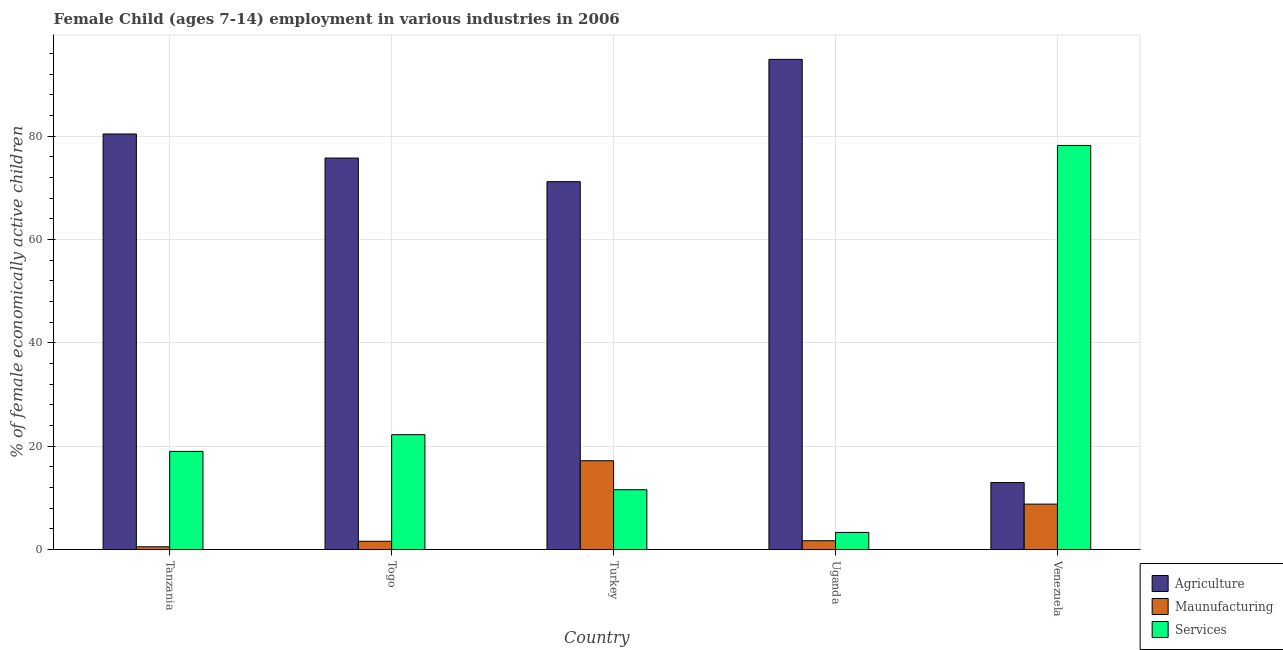How many groups of bars are there?
Ensure brevity in your answer.  5. Are the number of bars per tick equal to the number of legend labels?
Ensure brevity in your answer.  Yes. How many bars are there on the 1st tick from the left?
Make the answer very short. 3. How many bars are there on the 1st tick from the right?
Your answer should be compact. 3. What is the label of the 5th group of bars from the left?
Provide a short and direct response. Venezuela. What is the percentage of economically active children in manufacturing in Uganda?
Your response must be concise. 1.71. Across all countries, what is the maximum percentage of economically active children in manufacturing?
Your answer should be very brief. 17.2. Across all countries, what is the minimum percentage of economically active children in agriculture?
Provide a short and direct response. 12.97. In which country was the percentage of economically active children in services maximum?
Offer a terse response. Venezuela. In which country was the percentage of economically active children in manufacturing minimum?
Your answer should be compact. Tanzania. What is the total percentage of economically active children in agriculture in the graph?
Your answer should be compact. 335.32. What is the difference between the percentage of economically active children in services in Tanzania and that in Togo?
Ensure brevity in your answer.  -3.23. What is the difference between the percentage of economically active children in agriculture in Togo and the percentage of economically active children in manufacturing in Tanzania?
Provide a short and direct response. 75.25. What is the average percentage of economically active children in agriculture per country?
Provide a succinct answer. 67.06. What is the difference between the percentage of economically active children in manufacturing and percentage of economically active children in agriculture in Turkey?
Offer a very short reply. -54.02. In how many countries, is the percentage of economically active children in manufacturing greater than 32 %?
Ensure brevity in your answer.  0. What is the ratio of the percentage of economically active children in agriculture in Turkey to that in Venezuela?
Offer a terse response. 5.49. Is the percentage of economically active children in manufacturing in Togo less than that in Uganda?
Your response must be concise. Yes. What is the difference between the highest and the second highest percentage of economically active children in manufacturing?
Ensure brevity in your answer.  8.4. What is the difference between the highest and the lowest percentage of economically active children in services?
Your answer should be very brief. 74.91. What does the 3rd bar from the left in Venezuela represents?
Ensure brevity in your answer.  Services. What does the 2nd bar from the right in Togo represents?
Provide a short and direct response. Maunufacturing. How many bars are there?
Provide a succinct answer. 15. Are all the bars in the graph horizontal?
Offer a very short reply. No. How many countries are there in the graph?
Make the answer very short. 5. Does the graph contain any zero values?
Provide a succinct answer. No. What is the title of the graph?
Offer a very short reply. Female Child (ages 7-14) employment in various industries in 2006. What is the label or title of the Y-axis?
Your answer should be compact. % of female economically active children. What is the % of female economically active children of Agriculture in Tanzania?
Your response must be concise. 80.45. What is the % of female economically active children of Maunufacturing in Tanzania?
Your response must be concise. 0.54. What is the % of female economically active children of Services in Tanzania?
Your answer should be compact. 19.01. What is the % of female economically active children in Agriculture in Togo?
Provide a short and direct response. 75.79. What is the % of female economically active children of Maunufacturing in Togo?
Make the answer very short. 1.61. What is the % of female economically active children of Services in Togo?
Provide a succinct answer. 22.24. What is the % of female economically active children in Agriculture in Turkey?
Make the answer very short. 71.22. What is the % of female economically active children in Services in Turkey?
Provide a short and direct response. 11.58. What is the % of female economically active children of Agriculture in Uganda?
Offer a very short reply. 94.89. What is the % of female economically active children in Maunufacturing in Uganda?
Offer a very short reply. 1.71. What is the % of female economically active children in Services in Uganda?
Offer a very short reply. 3.32. What is the % of female economically active children of Agriculture in Venezuela?
Your response must be concise. 12.97. What is the % of female economically active children of Services in Venezuela?
Offer a very short reply. 78.23. Across all countries, what is the maximum % of female economically active children in Agriculture?
Offer a very short reply. 94.89. Across all countries, what is the maximum % of female economically active children of Services?
Your answer should be very brief. 78.23. Across all countries, what is the minimum % of female economically active children of Agriculture?
Your response must be concise. 12.97. Across all countries, what is the minimum % of female economically active children in Maunufacturing?
Provide a short and direct response. 0.54. Across all countries, what is the minimum % of female economically active children of Services?
Ensure brevity in your answer.  3.32. What is the total % of female economically active children in Agriculture in the graph?
Your response must be concise. 335.32. What is the total % of female economically active children in Maunufacturing in the graph?
Keep it short and to the point. 29.86. What is the total % of female economically active children in Services in the graph?
Keep it short and to the point. 134.38. What is the difference between the % of female economically active children of Agriculture in Tanzania and that in Togo?
Keep it short and to the point. 4.66. What is the difference between the % of female economically active children in Maunufacturing in Tanzania and that in Togo?
Ensure brevity in your answer.  -1.07. What is the difference between the % of female economically active children in Services in Tanzania and that in Togo?
Offer a terse response. -3.23. What is the difference between the % of female economically active children of Agriculture in Tanzania and that in Turkey?
Your response must be concise. 9.23. What is the difference between the % of female economically active children in Maunufacturing in Tanzania and that in Turkey?
Provide a succinct answer. -16.66. What is the difference between the % of female economically active children of Services in Tanzania and that in Turkey?
Provide a succinct answer. 7.43. What is the difference between the % of female economically active children of Agriculture in Tanzania and that in Uganda?
Give a very brief answer. -14.44. What is the difference between the % of female economically active children in Maunufacturing in Tanzania and that in Uganda?
Your answer should be compact. -1.17. What is the difference between the % of female economically active children in Services in Tanzania and that in Uganda?
Give a very brief answer. 15.69. What is the difference between the % of female economically active children of Agriculture in Tanzania and that in Venezuela?
Give a very brief answer. 67.48. What is the difference between the % of female economically active children in Maunufacturing in Tanzania and that in Venezuela?
Your response must be concise. -8.26. What is the difference between the % of female economically active children of Services in Tanzania and that in Venezuela?
Offer a terse response. -59.22. What is the difference between the % of female economically active children of Agriculture in Togo and that in Turkey?
Ensure brevity in your answer.  4.57. What is the difference between the % of female economically active children of Maunufacturing in Togo and that in Turkey?
Provide a short and direct response. -15.59. What is the difference between the % of female economically active children in Services in Togo and that in Turkey?
Your response must be concise. 10.66. What is the difference between the % of female economically active children of Agriculture in Togo and that in Uganda?
Your answer should be very brief. -19.1. What is the difference between the % of female economically active children of Maunufacturing in Togo and that in Uganda?
Your response must be concise. -0.1. What is the difference between the % of female economically active children in Services in Togo and that in Uganda?
Offer a very short reply. 18.92. What is the difference between the % of female economically active children in Agriculture in Togo and that in Venezuela?
Keep it short and to the point. 62.82. What is the difference between the % of female economically active children of Maunufacturing in Togo and that in Venezuela?
Offer a very short reply. -7.19. What is the difference between the % of female economically active children of Services in Togo and that in Venezuela?
Make the answer very short. -55.99. What is the difference between the % of female economically active children of Agriculture in Turkey and that in Uganda?
Keep it short and to the point. -23.67. What is the difference between the % of female economically active children of Maunufacturing in Turkey and that in Uganda?
Give a very brief answer. 15.49. What is the difference between the % of female economically active children in Services in Turkey and that in Uganda?
Keep it short and to the point. 8.26. What is the difference between the % of female economically active children of Agriculture in Turkey and that in Venezuela?
Your answer should be compact. 58.25. What is the difference between the % of female economically active children in Services in Turkey and that in Venezuela?
Offer a very short reply. -66.65. What is the difference between the % of female economically active children in Agriculture in Uganda and that in Venezuela?
Your answer should be very brief. 81.92. What is the difference between the % of female economically active children of Maunufacturing in Uganda and that in Venezuela?
Provide a short and direct response. -7.09. What is the difference between the % of female economically active children in Services in Uganda and that in Venezuela?
Your answer should be compact. -74.91. What is the difference between the % of female economically active children in Agriculture in Tanzania and the % of female economically active children in Maunufacturing in Togo?
Offer a very short reply. 78.84. What is the difference between the % of female economically active children of Agriculture in Tanzania and the % of female economically active children of Services in Togo?
Provide a short and direct response. 58.21. What is the difference between the % of female economically active children in Maunufacturing in Tanzania and the % of female economically active children in Services in Togo?
Ensure brevity in your answer.  -21.7. What is the difference between the % of female economically active children of Agriculture in Tanzania and the % of female economically active children of Maunufacturing in Turkey?
Give a very brief answer. 63.25. What is the difference between the % of female economically active children in Agriculture in Tanzania and the % of female economically active children in Services in Turkey?
Your answer should be compact. 68.87. What is the difference between the % of female economically active children in Maunufacturing in Tanzania and the % of female economically active children in Services in Turkey?
Offer a terse response. -11.04. What is the difference between the % of female economically active children of Agriculture in Tanzania and the % of female economically active children of Maunufacturing in Uganda?
Ensure brevity in your answer.  78.74. What is the difference between the % of female economically active children in Agriculture in Tanzania and the % of female economically active children in Services in Uganda?
Give a very brief answer. 77.13. What is the difference between the % of female economically active children of Maunufacturing in Tanzania and the % of female economically active children of Services in Uganda?
Provide a short and direct response. -2.78. What is the difference between the % of female economically active children of Agriculture in Tanzania and the % of female economically active children of Maunufacturing in Venezuela?
Your response must be concise. 71.65. What is the difference between the % of female economically active children in Agriculture in Tanzania and the % of female economically active children in Services in Venezuela?
Offer a terse response. 2.22. What is the difference between the % of female economically active children of Maunufacturing in Tanzania and the % of female economically active children of Services in Venezuela?
Offer a very short reply. -77.69. What is the difference between the % of female economically active children in Agriculture in Togo and the % of female economically active children in Maunufacturing in Turkey?
Provide a short and direct response. 58.59. What is the difference between the % of female economically active children of Agriculture in Togo and the % of female economically active children of Services in Turkey?
Your answer should be very brief. 64.21. What is the difference between the % of female economically active children in Maunufacturing in Togo and the % of female economically active children in Services in Turkey?
Offer a very short reply. -9.97. What is the difference between the % of female economically active children of Agriculture in Togo and the % of female economically active children of Maunufacturing in Uganda?
Your answer should be compact. 74.08. What is the difference between the % of female economically active children in Agriculture in Togo and the % of female economically active children in Services in Uganda?
Offer a very short reply. 72.47. What is the difference between the % of female economically active children of Maunufacturing in Togo and the % of female economically active children of Services in Uganda?
Offer a terse response. -1.71. What is the difference between the % of female economically active children in Agriculture in Togo and the % of female economically active children in Maunufacturing in Venezuela?
Keep it short and to the point. 66.99. What is the difference between the % of female economically active children in Agriculture in Togo and the % of female economically active children in Services in Venezuela?
Offer a terse response. -2.44. What is the difference between the % of female economically active children of Maunufacturing in Togo and the % of female economically active children of Services in Venezuela?
Ensure brevity in your answer.  -76.62. What is the difference between the % of female economically active children in Agriculture in Turkey and the % of female economically active children in Maunufacturing in Uganda?
Your answer should be very brief. 69.51. What is the difference between the % of female economically active children of Agriculture in Turkey and the % of female economically active children of Services in Uganda?
Give a very brief answer. 67.9. What is the difference between the % of female economically active children of Maunufacturing in Turkey and the % of female economically active children of Services in Uganda?
Provide a short and direct response. 13.88. What is the difference between the % of female economically active children of Agriculture in Turkey and the % of female economically active children of Maunufacturing in Venezuela?
Give a very brief answer. 62.42. What is the difference between the % of female economically active children in Agriculture in Turkey and the % of female economically active children in Services in Venezuela?
Provide a short and direct response. -7.01. What is the difference between the % of female economically active children in Maunufacturing in Turkey and the % of female economically active children in Services in Venezuela?
Give a very brief answer. -61.03. What is the difference between the % of female economically active children in Agriculture in Uganda and the % of female economically active children in Maunufacturing in Venezuela?
Give a very brief answer. 86.09. What is the difference between the % of female economically active children of Agriculture in Uganda and the % of female economically active children of Services in Venezuela?
Give a very brief answer. 16.66. What is the difference between the % of female economically active children of Maunufacturing in Uganda and the % of female economically active children of Services in Venezuela?
Offer a very short reply. -76.52. What is the average % of female economically active children in Agriculture per country?
Offer a very short reply. 67.06. What is the average % of female economically active children in Maunufacturing per country?
Your answer should be compact. 5.97. What is the average % of female economically active children in Services per country?
Your response must be concise. 26.88. What is the difference between the % of female economically active children in Agriculture and % of female economically active children in Maunufacturing in Tanzania?
Give a very brief answer. 79.91. What is the difference between the % of female economically active children of Agriculture and % of female economically active children of Services in Tanzania?
Give a very brief answer. 61.44. What is the difference between the % of female economically active children of Maunufacturing and % of female economically active children of Services in Tanzania?
Offer a terse response. -18.47. What is the difference between the % of female economically active children of Agriculture and % of female economically active children of Maunufacturing in Togo?
Your answer should be compact. 74.18. What is the difference between the % of female economically active children in Agriculture and % of female economically active children in Services in Togo?
Offer a terse response. 53.55. What is the difference between the % of female economically active children in Maunufacturing and % of female economically active children in Services in Togo?
Keep it short and to the point. -20.63. What is the difference between the % of female economically active children of Agriculture and % of female economically active children of Maunufacturing in Turkey?
Make the answer very short. 54.02. What is the difference between the % of female economically active children of Agriculture and % of female economically active children of Services in Turkey?
Ensure brevity in your answer.  59.64. What is the difference between the % of female economically active children of Maunufacturing and % of female economically active children of Services in Turkey?
Give a very brief answer. 5.62. What is the difference between the % of female economically active children in Agriculture and % of female economically active children in Maunufacturing in Uganda?
Make the answer very short. 93.18. What is the difference between the % of female economically active children of Agriculture and % of female economically active children of Services in Uganda?
Provide a succinct answer. 91.57. What is the difference between the % of female economically active children in Maunufacturing and % of female economically active children in Services in Uganda?
Keep it short and to the point. -1.61. What is the difference between the % of female economically active children in Agriculture and % of female economically active children in Maunufacturing in Venezuela?
Keep it short and to the point. 4.17. What is the difference between the % of female economically active children in Agriculture and % of female economically active children in Services in Venezuela?
Give a very brief answer. -65.26. What is the difference between the % of female economically active children of Maunufacturing and % of female economically active children of Services in Venezuela?
Ensure brevity in your answer.  -69.43. What is the ratio of the % of female economically active children in Agriculture in Tanzania to that in Togo?
Offer a terse response. 1.06. What is the ratio of the % of female economically active children of Maunufacturing in Tanzania to that in Togo?
Your answer should be compact. 0.34. What is the ratio of the % of female economically active children in Services in Tanzania to that in Togo?
Offer a very short reply. 0.85. What is the ratio of the % of female economically active children in Agriculture in Tanzania to that in Turkey?
Provide a short and direct response. 1.13. What is the ratio of the % of female economically active children of Maunufacturing in Tanzania to that in Turkey?
Provide a succinct answer. 0.03. What is the ratio of the % of female economically active children in Services in Tanzania to that in Turkey?
Offer a terse response. 1.64. What is the ratio of the % of female economically active children of Agriculture in Tanzania to that in Uganda?
Your response must be concise. 0.85. What is the ratio of the % of female economically active children of Maunufacturing in Tanzania to that in Uganda?
Your answer should be very brief. 0.32. What is the ratio of the % of female economically active children of Services in Tanzania to that in Uganda?
Make the answer very short. 5.73. What is the ratio of the % of female economically active children in Agriculture in Tanzania to that in Venezuela?
Provide a succinct answer. 6.2. What is the ratio of the % of female economically active children of Maunufacturing in Tanzania to that in Venezuela?
Your response must be concise. 0.06. What is the ratio of the % of female economically active children in Services in Tanzania to that in Venezuela?
Your answer should be very brief. 0.24. What is the ratio of the % of female economically active children of Agriculture in Togo to that in Turkey?
Ensure brevity in your answer.  1.06. What is the ratio of the % of female economically active children in Maunufacturing in Togo to that in Turkey?
Provide a succinct answer. 0.09. What is the ratio of the % of female economically active children of Services in Togo to that in Turkey?
Offer a very short reply. 1.92. What is the ratio of the % of female economically active children of Agriculture in Togo to that in Uganda?
Provide a short and direct response. 0.8. What is the ratio of the % of female economically active children of Maunufacturing in Togo to that in Uganda?
Make the answer very short. 0.94. What is the ratio of the % of female economically active children of Services in Togo to that in Uganda?
Make the answer very short. 6.7. What is the ratio of the % of female economically active children of Agriculture in Togo to that in Venezuela?
Ensure brevity in your answer.  5.84. What is the ratio of the % of female economically active children of Maunufacturing in Togo to that in Venezuela?
Your response must be concise. 0.18. What is the ratio of the % of female economically active children in Services in Togo to that in Venezuela?
Your response must be concise. 0.28. What is the ratio of the % of female economically active children of Agriculture in Turkey to that in Uganda?
Make the answer very short. 0.75. What is the ratio of the % of female economically active children of Maunufacturing in Turkey to that in Uganda?
Provide a succinct answer. 10.06. What is the ratio of the % of female economically active children of Services in Turkey to that in Uganda?
Make the answer very short. 3.49. What is the ratio of the % of female economically active children in Agriculture in Turkey to that in Venezuela?
Keep it short and to the point. 5.49. What is the ratio of the % of female economically active children of Maunufacturing in Turkey to that in Venezuela?
Your answer should be compact. 1.95. What is the ratio of the % of female economically active children in Services in Turkey to that in Venezuela?
Provide a short and direct response. 0.15. What is the ratio of the % of female economically active children of Agriculture in Uganda to that in Venezuela?
Make the answer very short. 7.32. What is the ratio of the % of female economically active children of Maunufacturing in Uganda to that in Venezuela?
Your answer should be compact. 0.19. What is the ratio of the % of female economically active children of Services in Uganda to that in Venezuela?
Provide a short and direct response. 0.04. What is the difference between the highest and the second highest % of female economically active children of Agriculture?
Offer a terse response. 14.44. What is the difference between the highest and the second highest % of female economically active children in Services?
Offer a very short reply. 55.99. What is the difference between the highest and the lowest % of female economically active children of Agriculture?
Provide a succinct answer. 81.92. What is the difference between the highest and the lowest % of female economically active children of Maunufacturing?
Provide a succinct answer. 16.66. What is the difference between the highest and the lowest % of female economically active children in Services?
Offer a terse response. 74.91. 